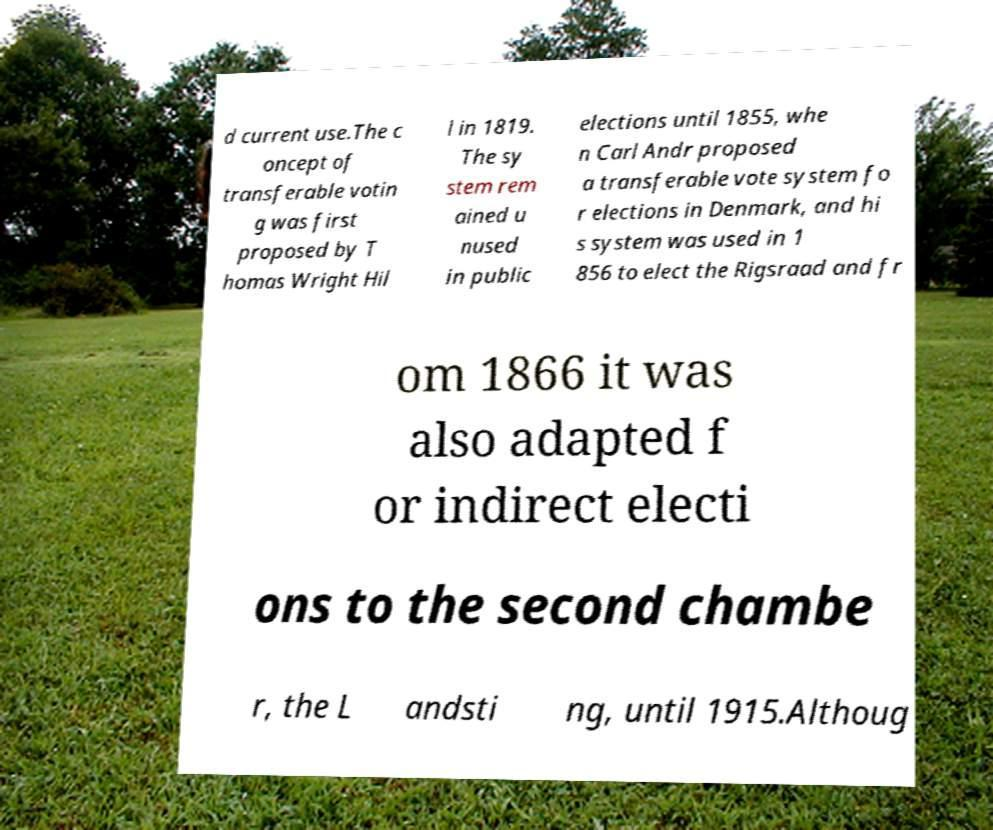I need the written content from this picture converted into text. Can you do that? d current use.The c oncept of transferable votin g was first proposed by T homas Wright Hil l in 1819. The sy stem rem ained u nused in public elections until 1855, whe n Carl Andr proposed a transferable vote system fo r elections in Denmark, and hi s system was used in 1 856 to elect the Rigsraad and fr om 1866 it was also adapted f or indirect electi ons to the second chambe r, the L andsti ng, until 1915.Althoug 